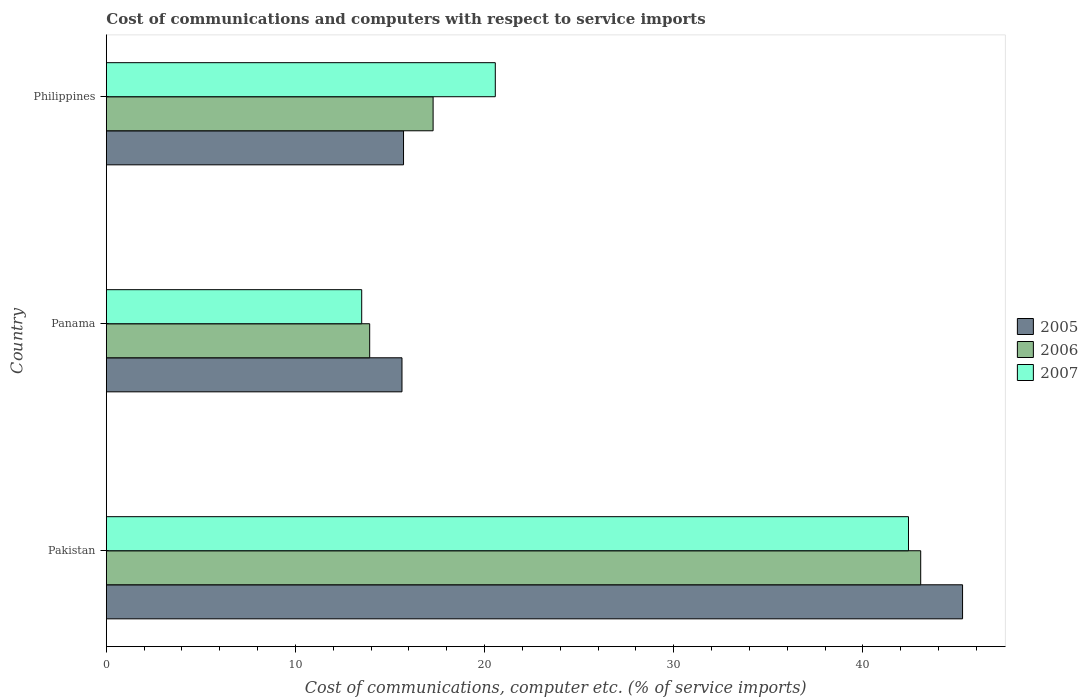How many bars are there on the 2nd tick from the top?
Offer a very short reply. 3. How many bars are there on the 3rd tick from the bottom?
Provide a short and direct response. 3. What is the label of the 1st group of bars from the top?
Offer a terse response. Philippines. In how many cases, is the number of bars for a given country not equal to the number of legend labels?
Offer a very short reply. 0. What is the cost of communications and computers in 2005 in Panama?
Offer a very short reply. 15.63. Across all countries, what is the maximum cost of communications and computers in 2005?
Ensure brevity in your answer.  45.27. Across all countries, what is the minimum cost of communications and computers in 2005?
Offer a very short reply. 15.63. In which country was the cost of communications and computers in 2007 minimum?
Offer a very short reply. Panama. What is the total cost of communications and computers in 2005 in the graph?
Ensure brevity in your answer.  76.62. What is the difference between the cost of communications and computers in 2006 in Panama and that in Philippines?
Offer a very short reply. -3.35. What is the difference between the cost of communications and computers in 2005 in Panama and the cost of communications and computers in 2007 in Philippines?
Offer a very short reply. -4.93. What is the average cost of communications and computers in 2005 per country?
Provide a succinct answer. 25.54. What is the difference between the cost of communications and computers in 2007 and cost of communications and computers in 2005 in Panama?
Give a very brief answer. -2.13. What is the ratio of the cost of communications and computers in 2007 in Pakistan to that in Philippines?
Provide a succinct answer. 2.06. Is the difference between the cost of communications and computers in 2007 in Panama and Philippines greater than the difference between the cost of communications and computers in 2005 in Panama and Philippines?
Keep it short and to the point. No. What is the difference between the highest and the second highest cost of communications and computers in 2005?
Provide a short and direct response. 29.56. What is the difference between the highest and the lowest cost of communications and computers in 2006?
Provide a short and direct response. 29.13. In how many countries, is the cost of communications and computers in 2007 greater than the average cost of communications and computers in 2007 taken over all countries?
Ensure brevity in your answer.  1. Are all the bars in the graph horizontal?
Keep it short and to the point. Yes. How many countries are there in the graph?
Your answer should be very brief. 3. Are the values on the major ticks of X-axis written in scientific E-notation?
Ensure brevity in your answer.  No. Does the graph contain any zero values?
Make the answer very short. No. Where does the legend appear in the graph?
Keep it short and to the point. Center right. How many legend labels are there?
Offer a very short reply. 3. What is the title of the graph?
Your response must be concise. Cost of communications and computers with respect to service imports. What is the label or title of the X-axis?
Offer a very short reply. Cost of communications, computer etc. (% of service imports). What is the label or title of the Y-axis?
Ensure brevity in your answer.  Country. What is the Cost of communications, computer etc. (% of service imports) of 2005 in Pakistan?
Provide a short and direct response. 45.27. What is the Cost of communications, computer etc. (% of service imports) of 2006 in Pakistan?
Offer a terse response. 43.06. What is the Cost of communications, computer etc. (% of service imports) of 2007 in Pakistan?
Your answer should be very brief. 42.41. What is the Cost of communications, computer etc. (% of service imports) in 2005 in Panama?
Offer a terse response. 15.63. What is the Cost of communications, computer etc. (% of service imports) in 2006 in Panama?
Provide a short and direct response. 13.92. What is the Cost of communications, computer etc. (% of service imports) in 2007 in Panama?
Make the answer very short. 13.5. What is the Cost of communications, computer etc. (% of service imports) of 2005 in Philippines?
Give a very brief answer. 15.71. What is the Cost of communications, computer etc. (% of service imports) of 2006 in Philippines?
Your response must be concise. 17.28. What is the Cost of communications, computer etc. (% of service imports) of 2007 in Philippines?
Offer a very short reply. 20.57. Across all countries, what is the maximum Cost of communications, computer etc. (% of service imports) of 2005?
Keep it short and to the point. 45.27. Across all countries, what is the maximum Cost of communications, computer etc. (% of service imports) of 2006?
Provide a short and direct response. 43.06. Across all countries, what is the maximum Cost of communications, computer etc. (% of service imports) in 2007?
Give a very brief answer. 42.41. Across all countries, what is the minimum Cost of communications, computer etc. (% of service imports) of 2005?
Ensure brevity in your answer.  15.63. Across all countries, what is the minimum Cost of communications, computer etc. (% of service imports) in 2006?
Offer a terse response. 13.92. Across all countries, what is the minimum Cost of communications, computer etc. (% of service imports) of 2007?
Give a very brief answer. 13.5. What is the total Cost of communications, computer etc. (% of service imports) of 2005 in the graph?
Provide a succinct answer. 76.62. What is the total Cost of communications, computer etc. (% of service imports) of 2006 in the graph?
Provide a succinct answer. 74.26. What is the total Cost of communications, computer etc. (% of service imports) of 2007 in the graph?
Give a very brief answer. 76.48. What is the difference between the Cost of communications, computer etc. (% of service imports) in 2005 in Pakistan and that in Panama?
Your answer should be very brief. 29.64. What is the difference between the Cost of communications, computer etc. (% of service imports) in 2006 in Pakistan and that in Panama?
Provide a short and direct response. 29.13. What is the difference between the Cost of communications, computer etc. (% of service imports) of 2007 in Pakistan and that in Panama?
Provide a succinct answer. 28.91. What is the difference between the Cost of communications, computer etc. (% of service imports) of 2005 in Pakistan and that in Philippines?
Your answer should be compact. 29.56. What is the difference between the Cost of communications, computer etc. (% of service imports) in 2006 in Pakistan and that in Philippines?
Provide a short and direct response. 25.78. What is the difference between the Cost of communications, computer etc. (% of service imports) of 2007 in Pakistan and that in Philippines?
Your answer should be very brief. 21.85. What is the difference between the Cost of communications, computer etc. (% of service imports) of 2005 in Panama and that in Philippines?
Your answer should be very brief. -0.08. What is the difference between the Cost of communications, computer etc. (% of service imports) in 2006 in Panama and that in Philippines?
Your answer should be compact. -3.35. What is the difference between the Cost of communications, computer etc. (% of service imports) in 2007 in Panama and that in Philippines?
Keep it short and to the point. -7.06. What is the difference between the Cost of communications, computer etc. (% of service imports) in 2005 in Pakistan and the Cost of communications, computer etc. (% of service imports) in 2006 in Panama?
Ensure brevity in your answer.  31.35. What is the difference between the Cost of communications, computer etc. (% of service imports) in 2005 in Pakistan and the Cost of communications, computer etc. (% of service imports) in 2007 in Panama?
Offer a very short reply. 31.77. What is the difference between the Cost of communications, computer etc. (% of service imports) of 2006 in Pakistan and the Cost of communications, computer etc. (% of service imports) of 2007 in Panama?
Offer a very short reply. 29.55. What is the difference between the Cost of communications, computer etc. (% of service imports) in 2005 in Pakistan and the Cost of communications, computer etc. (% of service imports) in 2006 in Philippines?
Ensure brevity in your answer.  27.99. What is the difference between the Cost of communications, computer etc. (% of service imports) of 2005 in Pakistan and the Cost of communications, computer etc. (% of service imports) of 2007 in Philippines?
Provide a succinct answer. 24.7. What is the difference between the Cost of communications, computer etc. (% of service imports) in 2006 in Pakistan and the Cost of communications, computer etc. (% of service imports) in 2007 in Philippines?
Offer a very short reply. 22.49. What is the difference between the Cost of communications, computer etc. (% of service imports) in 2005 in Panama and the Cost of communications, computer etc. (% of service imports) in 2006 in Philippines?
Your answer should be very brief. -1.65. What is the difference between the Cost of communications, computer etc. (% of service imports) in 2005 in Panama and the Cost of communications, computer etc. (% of service imports) in 2007 in Philippines?
Keep it short and to the point. -4.93. What is the difference between the Cost of communications, computer etc. (% of service imports) of 2006 in Panama and the Cost of communications, computer etc. (% of service imports) of 2007 in Philippines?
Your answer should be very brief. -6.64. What is the average Cost of communications, computer etc. (% of service imports) in 2005 per country?
Offer a very short reply. 25.54. What is the average Cost of communications, computer etc. (% of service imports) in 2006 per country?
Give a very brief answer. 24.75. What is the average Cost of communications, computer etc. (% of service imports) of 2007 per country?
Make the answer very short. 25.49. What is the difference between the Cost of communications, computer etc. (% of service imports) of 2005 and Cost of communications, computer etc. (% of service imports) of 2006 in Pakistan?
Provide a short and direct response. 2.21. What is the difference between the Cost of communications, computer etc. (% of service imports) in 2005 and Cost of communications, computer etc. (% of service imports) in 2007 in Pakistan?
Keep it short and to the point. 2.86. What is the difference between the Cost of communications, computer etc. (% of service imports) in 2006 and Cost of communications, computer etc. (% of service imports) in 2007 in Pakistan?
Ensure brevity in your answer.  0.65. What is the difference between the Cost of communications, computer etc. (% of service imports) of 2005 and Cost of communications, computer etc. (% of service imports) of 2006 in Panama?
Make the answer very short. 1.71. What is the difference between the Cost of communications, computer etc. (% of service imports) in 2005 and Cost of communications, computer etc. (% of service imports) in 2007 in Panama?
Your response must be concise. 2.13. What is the difference between the Cost of communications, computer etc. (% of service imports) in 2006 and Cost of communications, computer etc. (% of service imports) in 2007 in Panama?
Your response must be concise. 0.42. What is the difference between the Cost of communications, computer etc. (% of service imports) of 2005 and Cost of communications, computer etc. (% of service imports) of 2006 in Philippines?
Keep it short and to the point. -1.56. What is the difference between the Cost of communications, computer etc. (% of service imports) of 2005 and Cost of communications, computer etc. (% of service imports) of 2007 in Philippines?
Provide a succinct answer. -4.85. What is the difference between the Cost of communications, computer etc. (% of service imports) in 2006 and Cost of communications, computer etc. (% of service imports) in 2007 in Philippines?
Give a very brief answer. -3.29. What is the ratio of the Cost of communications, computer etc. (% of service imports) in 2005 in Pakistan to that in Panama?
Make the answer very short. 2.9. What is the ratio of the Cost of communications, computer etc. (% of service imports) in 2006 in Pakistan to that in Panama?
Provide a short and direct response. 3.09. What is the ratio of the Cost of communications, computer etc. (% of service imports) in 2007 in Pakistan to that in Panama?
Give a very brief answer. 3.14. What is the ratio of the Cost of communications, computer etc. (% of service imports) of 2005 in Pakistan to that in Philippines?
Provide a succinct answer. 2.88. What is the ratio of the Cost of communications, computer etc. (% of service imports) in 2006 in Pakistan to that in Philippines?
Offer a terse response. 2.49. What is the ratio of the Cost of communications, computer etc. (% of service imports) in 2007 in Pakistan to that in Philippines?
Your answer should be compact. 2.06. What is the ratio of the Cost of communications, computer etc. (% of service imports) in 2006 in Panama to that in Philippines?
Make the answer very short. 0.81. What is the ratio of the Cost of communications, computer etc. (% of service imports) of 2007 in Panama to that in Philippines?
Offer a terse response. 0.66. What is the difference between the highest and the second highest Cost of communications, computer etc. (% of service imports) in 2005?
Give a very brief answer. 29.56. What is the difference between the highest and the second highest Cost of communications, computer etc. (% of service imports) of 2006?
Offer a terse response. 25.78. What is the difference between the highest and the second highest Cost of communications, computer etc. (% of service imports) of 2007?
Make the answer very short. 21.85. What is the difference between the highest and the lowest Cost of communications, computer etc. (% of service imports) in 2005?
Your response must be concise. 29.64. What is the difference between the highest and the lowest Cost of communications, computer etc. (% of service imports) in 2006?
Your answer should be compact. 29.13. What is the difference between the highest and the lowest Cost of communications, computer etc. (% of service imports) in 2007?
Offer a terse response. 28.91. 